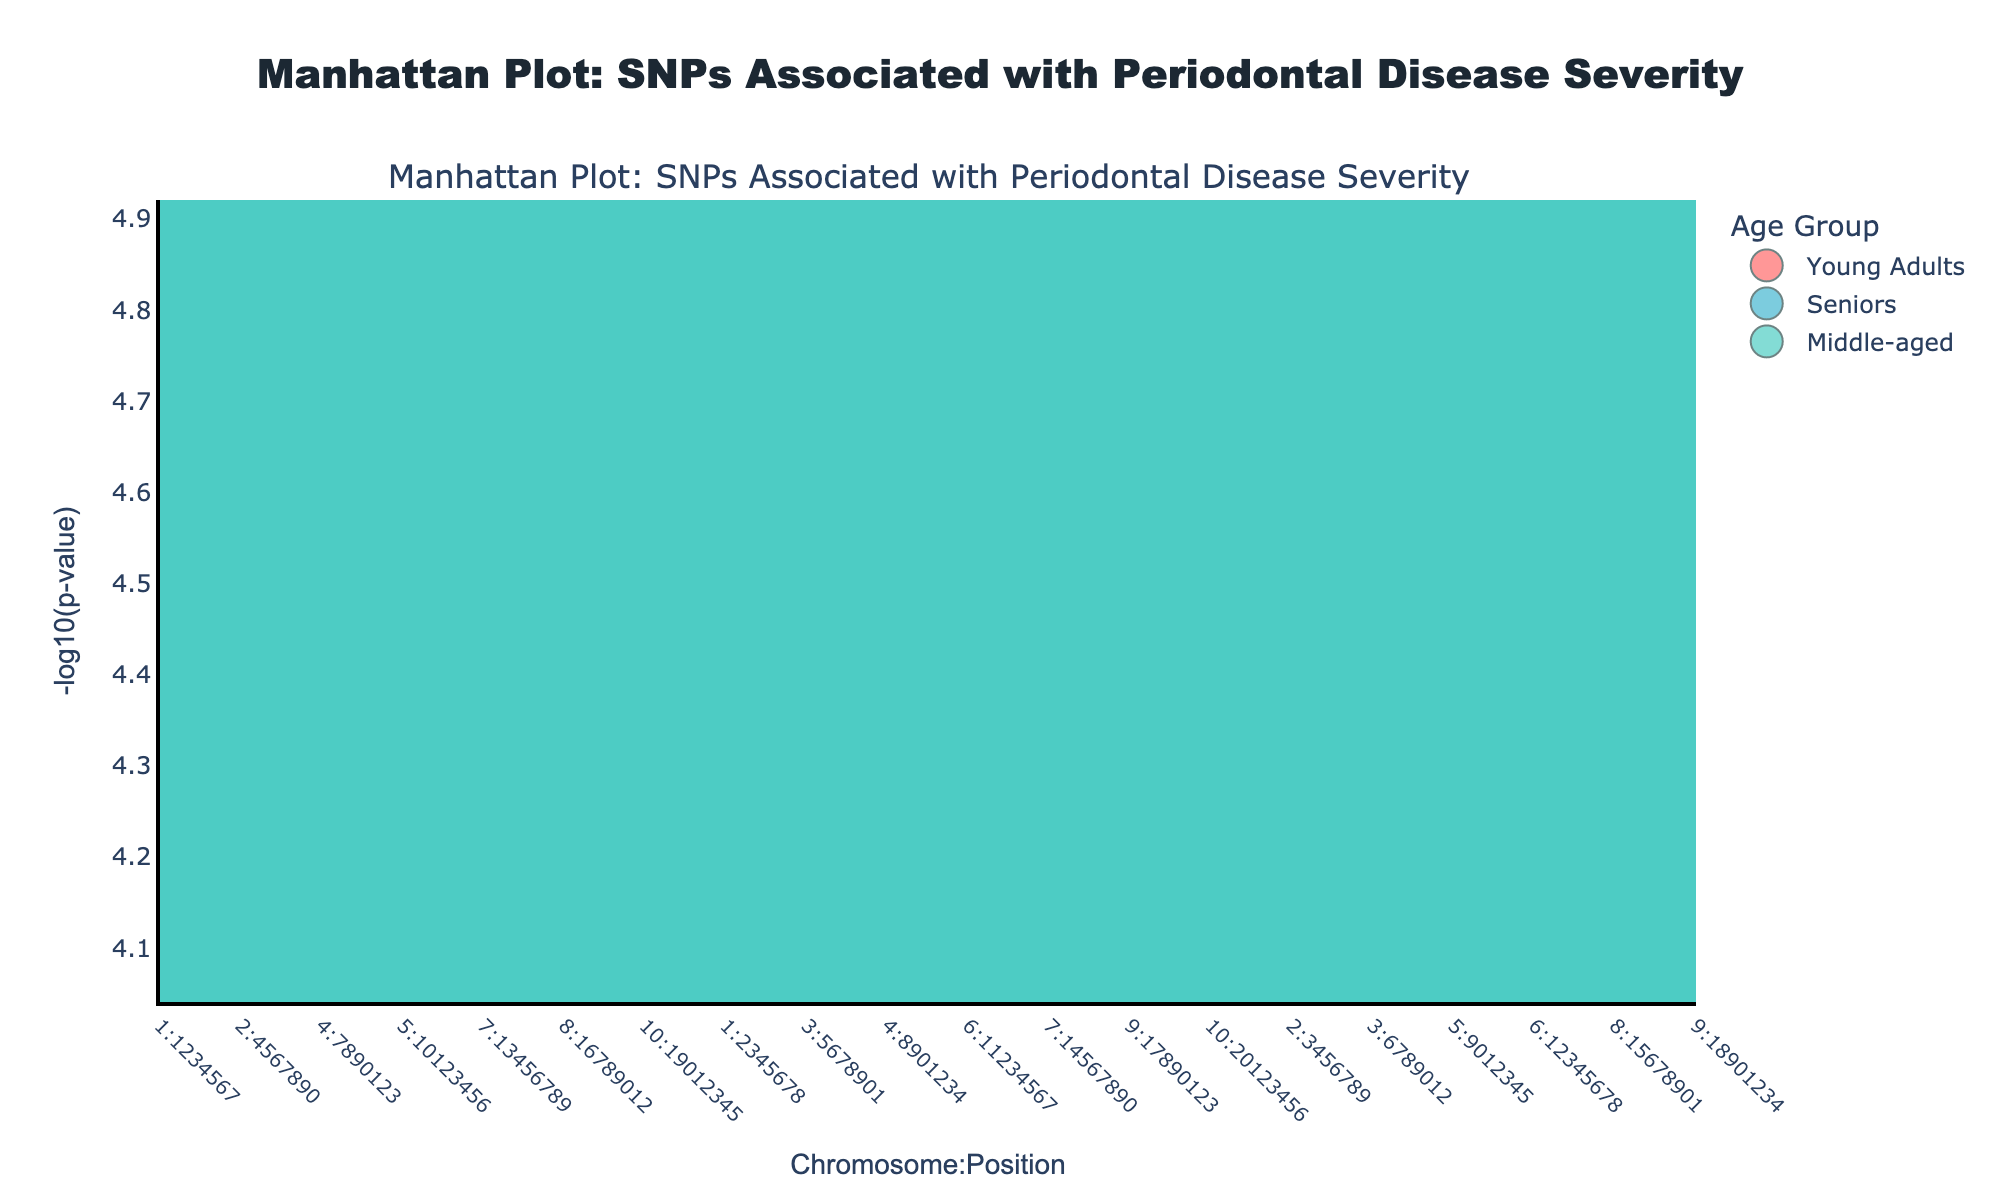What is the title of the Manhattan Plot? The title is found at the top of the plot, typically highlighted and centered. In this case, the title is "Manhattan Plot: SNPs Associated with Periodontal Disease Severity".
Answer: Manhattan Plot: SNPs Associated with Periodontal Disease Severity Which chromosome has the highest SNP association for Young Adults? Look for the chromosome with the highest -log10(p-value) points colored in pink (associated with Young Adults). The highest point is on Chromosome 1.
Answer: Chromosome 1 How many SNPs are represented in the plot for Middle-aged individuals? Count the markers in turquoise (associated with Middle-aged individuals). There are 5 markers.
Answer: 5 Which age group has the SNP with the lowest p-value? Identify the smallest p-value by finding the highest -log10(p-value). The color of this point will indicate the age group. The highest point is in pink which is associated with Young Adults, corresponding to SNP rs1801133 on Chromosome 1.
Answer: Young Adults How does the -log10(p-value) of SNP rs3811046 compare to SNP rs1800629? Locate both SNPs on the plot (rs3811046 in blue for Seniors and rs1800629 also in blue for Seniors). Compare their heights (y-axis values). rs3811046 has a higher -log10(p-value) than rs1800629.
Answer: rs3811046 has a higher -log10(p-value) Which age group has more SNPs with -log10(p-value) greater than 4.5? Determine the count of SNPs with -log10(p-value) > 4.5 for each age group based on their colors. Young Adults: 3 SNPs, Middle-aged: 2 SNPs, Seniors: 3 SNPs.
Answer: Young Adults and Seniors (tie) What is the color used to represent SNPs associated with Seniors? Check the legend on the plot for the color next to "Seniors". The color for Seniors is blue.
Answer: Blue Which chromosome has the most SNPs associated with disease severity in the plot? Count the SNP markers for each chromosome. Chromosome 5 has the most SNPs (2 SNPs: rs1800795 and rs1800796).
Answer: Chromosome 5 